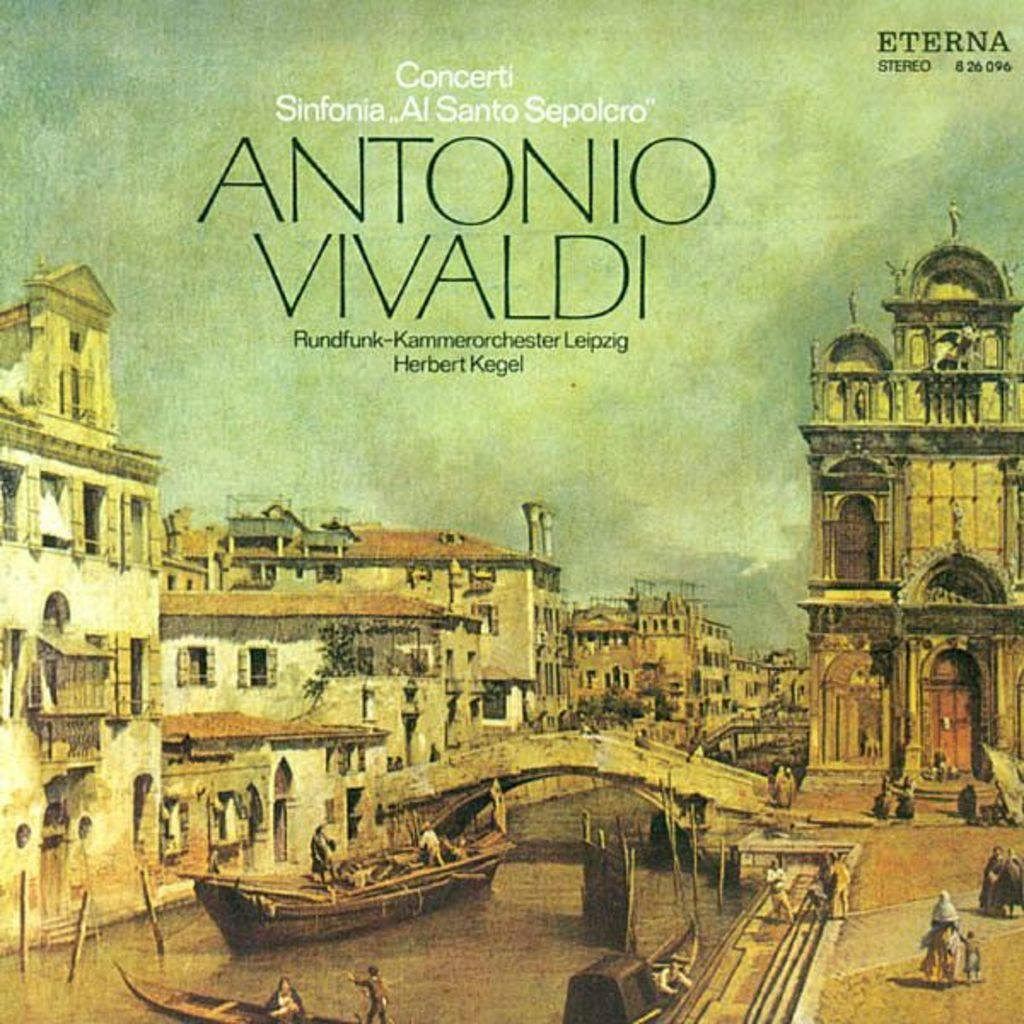<image>
Provide a brief description of the given image. A drawing of a city with the caption Antonio Vivaldi. 